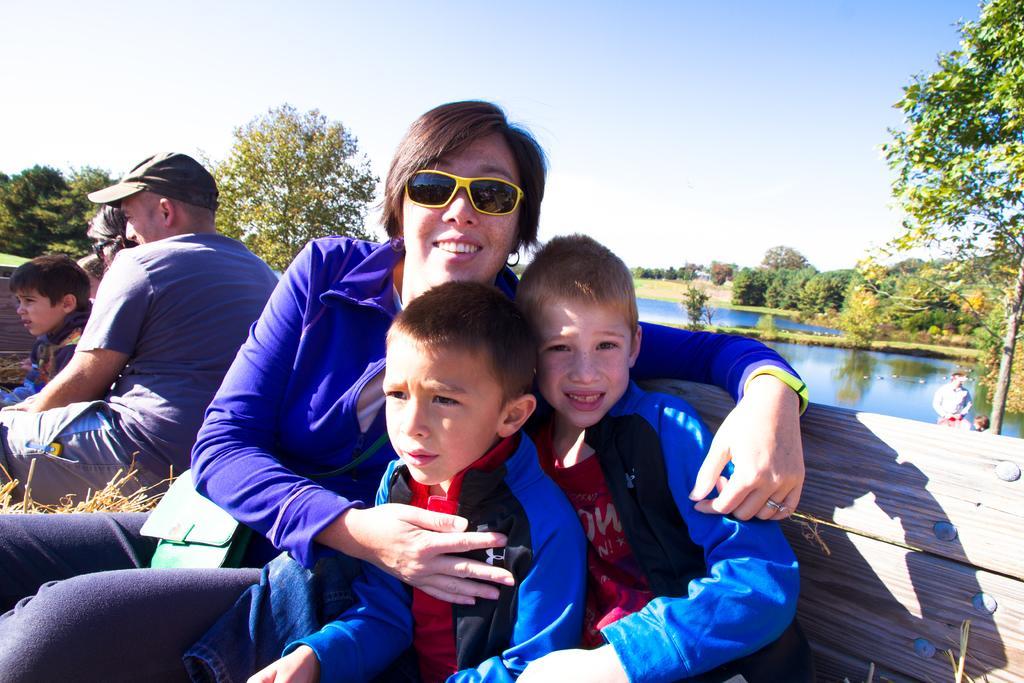In one or two sentences, can you explain what this image depicts? As we can see in the image there are trees, water, few people sitting on benches and on the top there is sky. 